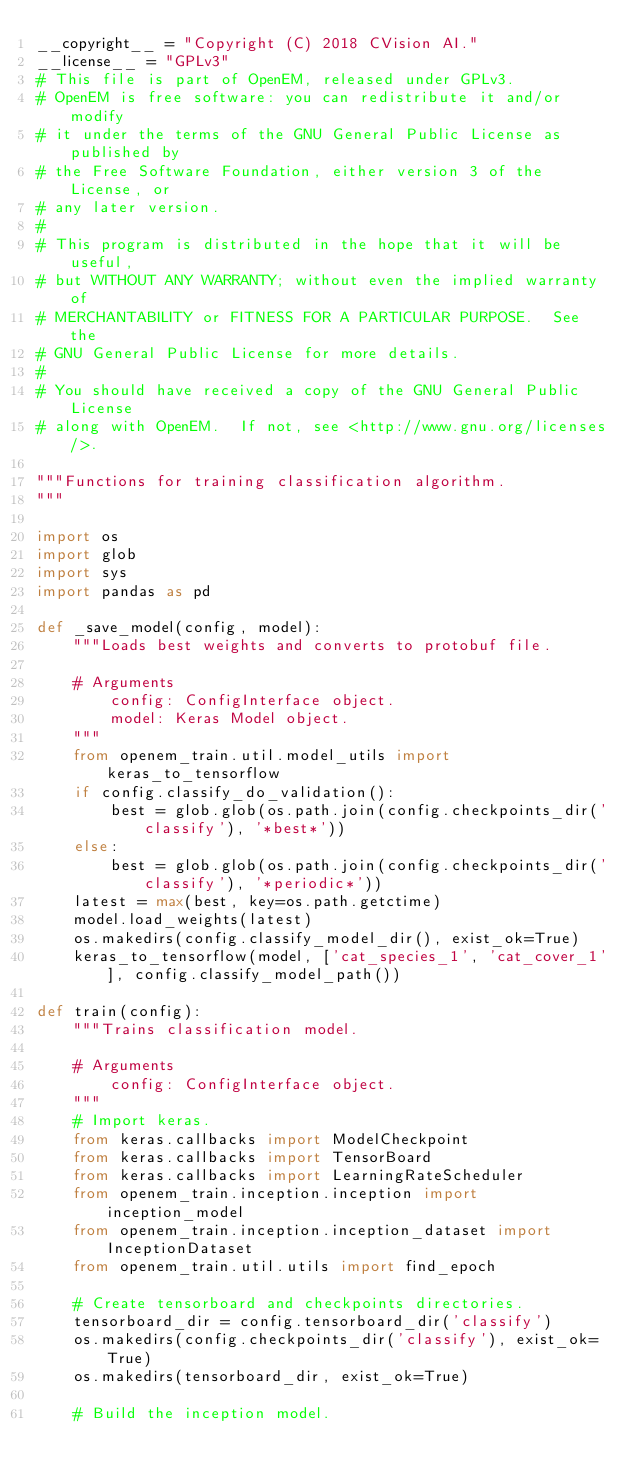Convert code to text. <code><loc_0><loc_0><loc_500><loc_500><_Python_>__copyright__ = "Copyright (C) 2018 CVision AI."
__license__ = "GPLv3"
# This file is part of OpenEM, released under GPLv3.
# OpenEM is free software: you can redistribute it and/or modify
# it under the terms of the GNU General Public License as published by
# the Free Software Foundation, either version 3 of the License, or
# any later version.
# 
# This program is distributed in the hope that it will be useful,
# but WITHOUT ANY WARRANTY; without even the implied warranty of
# MERCHANTABILITY or FITNESS FOR A PARTICULAR PURPOSE.  See the
# GNU General Public License for more details.
#
# You should have received a copy of the GNU General Public License
# along with OpenEM.  If not, see <http://www.gnu.org/licenses/>.

"""Functions for training classification algorithm.
"""

import os
import glob
import sys
import pandas as pd

def _save_model(config, model):
    """Loads best weights and converts to protobuf file.

    # Arguments
        config: ConfigInterface object.
        model: Keras Model object.
    """
    from openem_train.util.model_utils import keras_to_tensorflow
    if config.classify_do_validation():
        best = glob.glob(os.path.join(config.checkpoints_dir('classify'), '*best*'))
    else:
        best = glob.glob(os.path.join(config.checkpoints_dir('classify'), '*periodic*'))
    latest = max(best, key=os.path.getctime)
    model.load_weights(latest)
    os.makedirs(config.classify_model_dir(), exist_ok=True)
    keras_to_tensorflow(model, ['cat_species_1', 'cat_cover_1'], config.classify_model_path())

def train(config):
    """Trains classification model.

    # Arguments
        config: ConfigInterface object.
    """
    # Import keras.
    from keras.callbacks import ModelCheckpoint
    from keras.callbacks import TensorBoard
    from keras.callbacks import LearningRateScheduler
    from openem_train.inception.inception import inception_model
    from openem_train.inception.inception_dataset import InceptionDataset
    from openem_train.util.utils import find_epoch

    # Create tensorboard and checkpoints directories.
    tensorboard_dir = config.tensorboard_dir('classify')
    os.makedirs(config.checkpoints_dir('classify'), exist_ok=True)
    os.makedirs(tensorboard_dir, exist_ok=True)

    # Build the inception model.</code> 